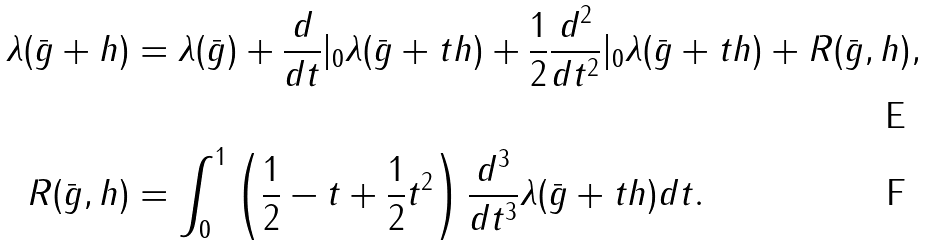Convert formula to latex. <formula><loc_0><loc_0><loc_500><loc_500>\lambda ( \bar { g } + h ) & = \lambda ( \bar { g } ) + \frac { d } { d t } | _ { 0 } \lambda ( \bar { g } + t h ) + \frac { 1 } { 2 } \frac { d ^ { 2 } } { d t ^ { 2 } } | _ { 0 } \lambda ( \bar { g } + t h ) + R ( \bar { g } , h ) , \\ R ( \bar { g } , h ) & = \int _ { 0 } ^ { 1 } \left ( \frac { 1 } { 2 } - t + \frac { 1 } { 2 } t ^ { 2 } \right ) \frac { d ^ { 3 } } { d t ^ { 3 } } \lambda ( \bar { g } + t h ) d t .</formula> 